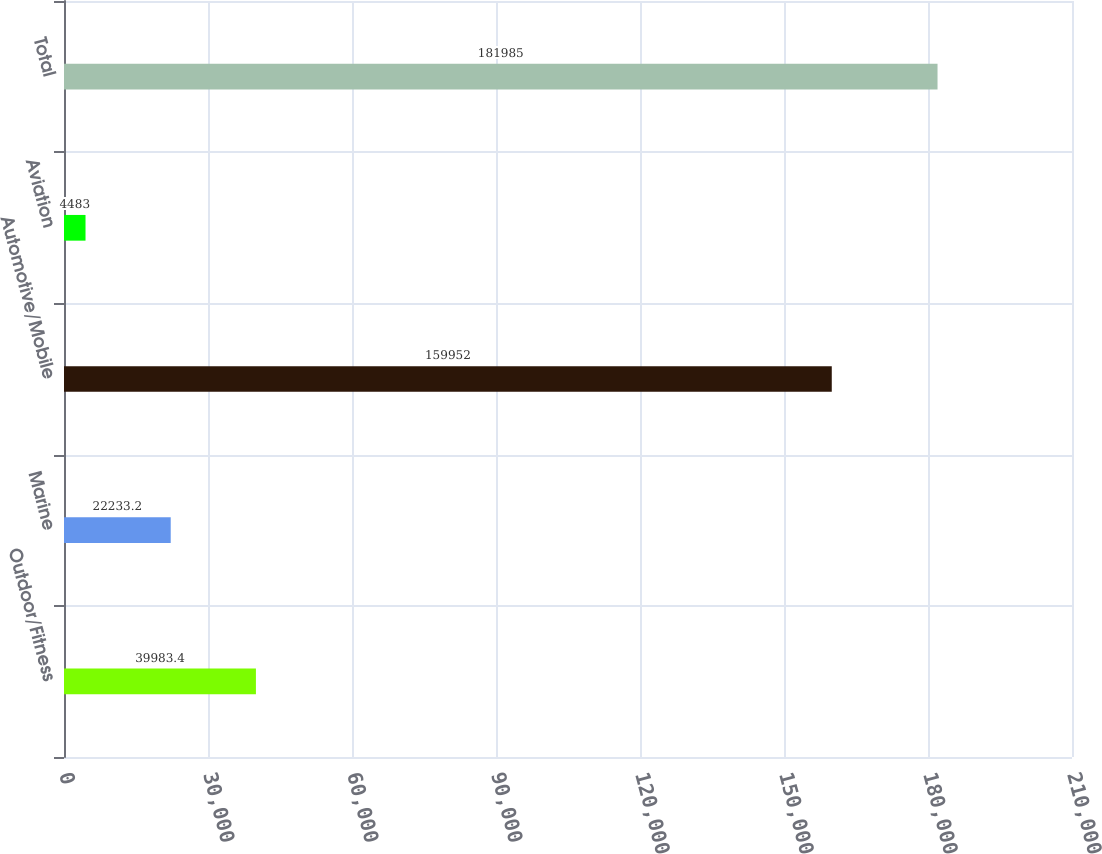<chart> <loc_0><loc_0><loc_500><loc_500><bar_chart><fcel>Outdoor/Fitness<fcel>Marine<fcel>Automotive/Mobile<fcel>Aviation<fcel>Total<nl><fcel>39983.4<fcel>22233.2<fcel>159952<fcel>4483<fcel>181985<nl></chart> 